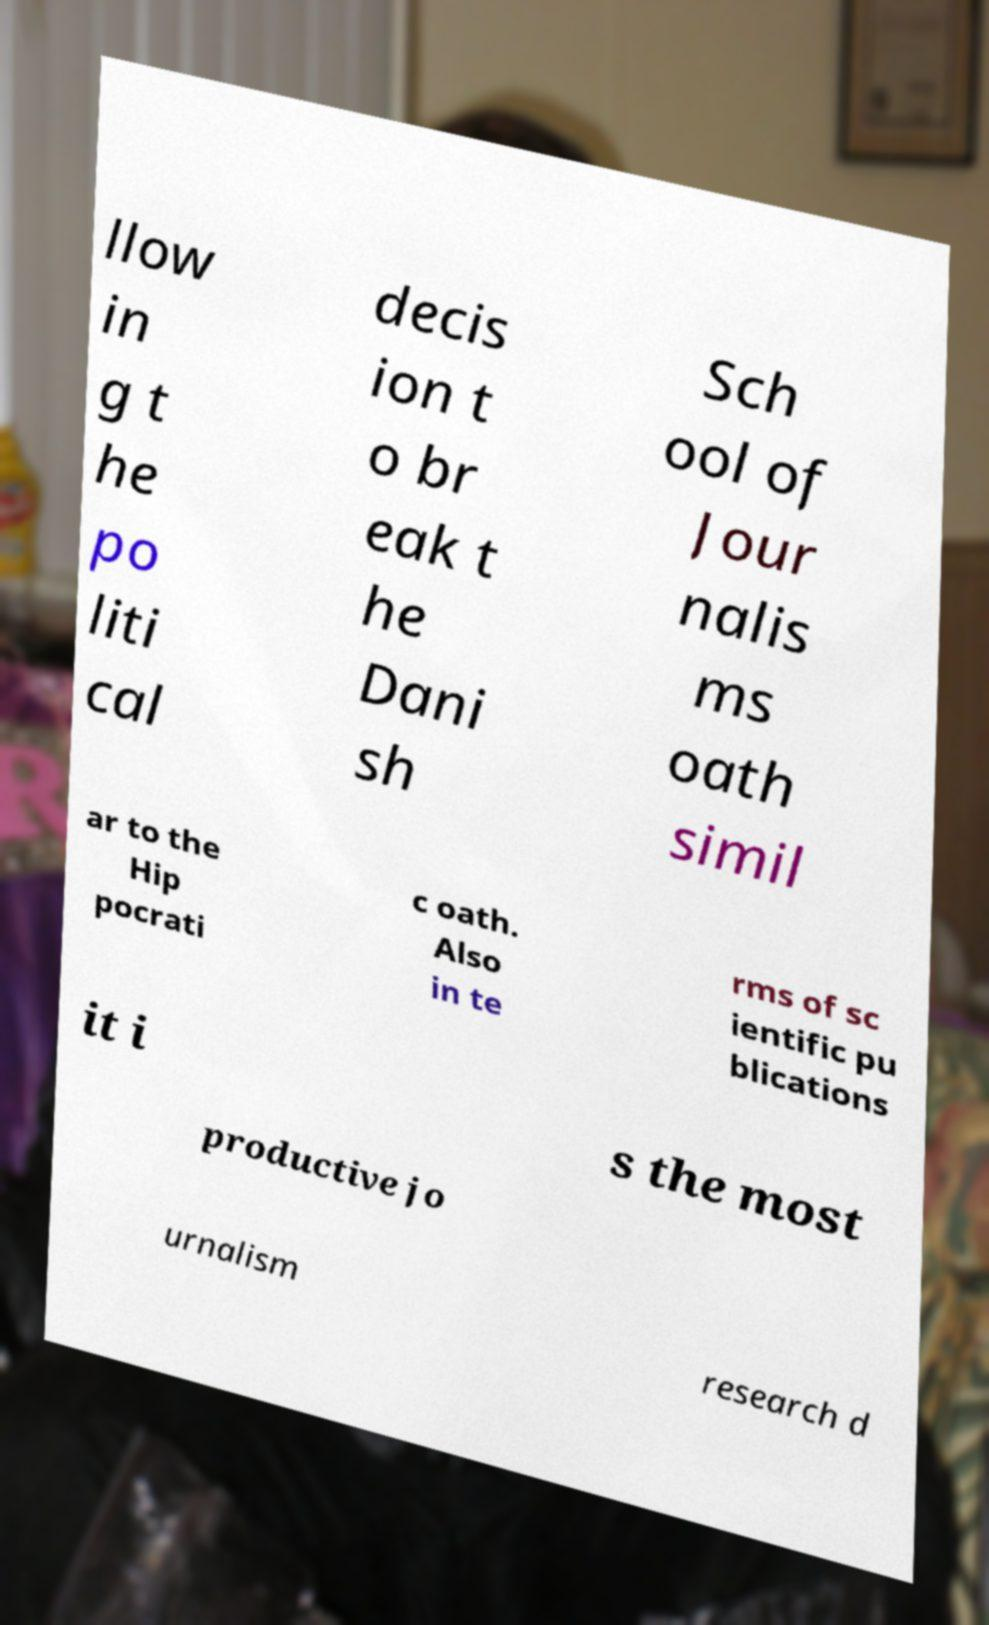I need the written content from this picture converted into text. Can you do that? llow in g t he po liti cal decis ion t o br eak t he Dani sh Sch ool of Jour nalis ms oath simil ar to the Hip pocrati c oath. Also in te rms of sc ientific pu blications it i s the most productive jo urnalism research d 